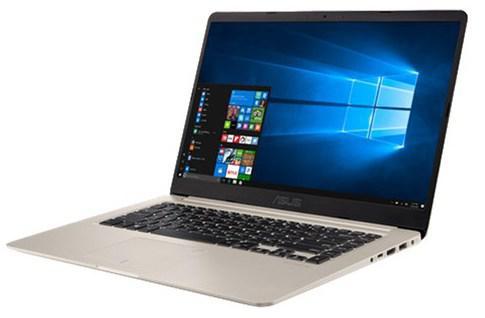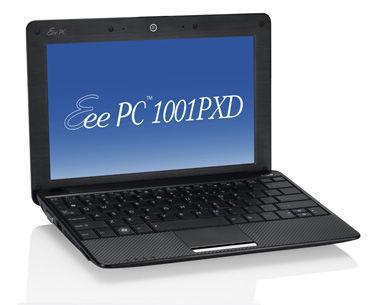The first image is the image on the left, the second image is the image on the right. For the images shown, is this caption "The laptop on the left image has a silver body around the keyboard." true? Answer yes or no. Yes. 